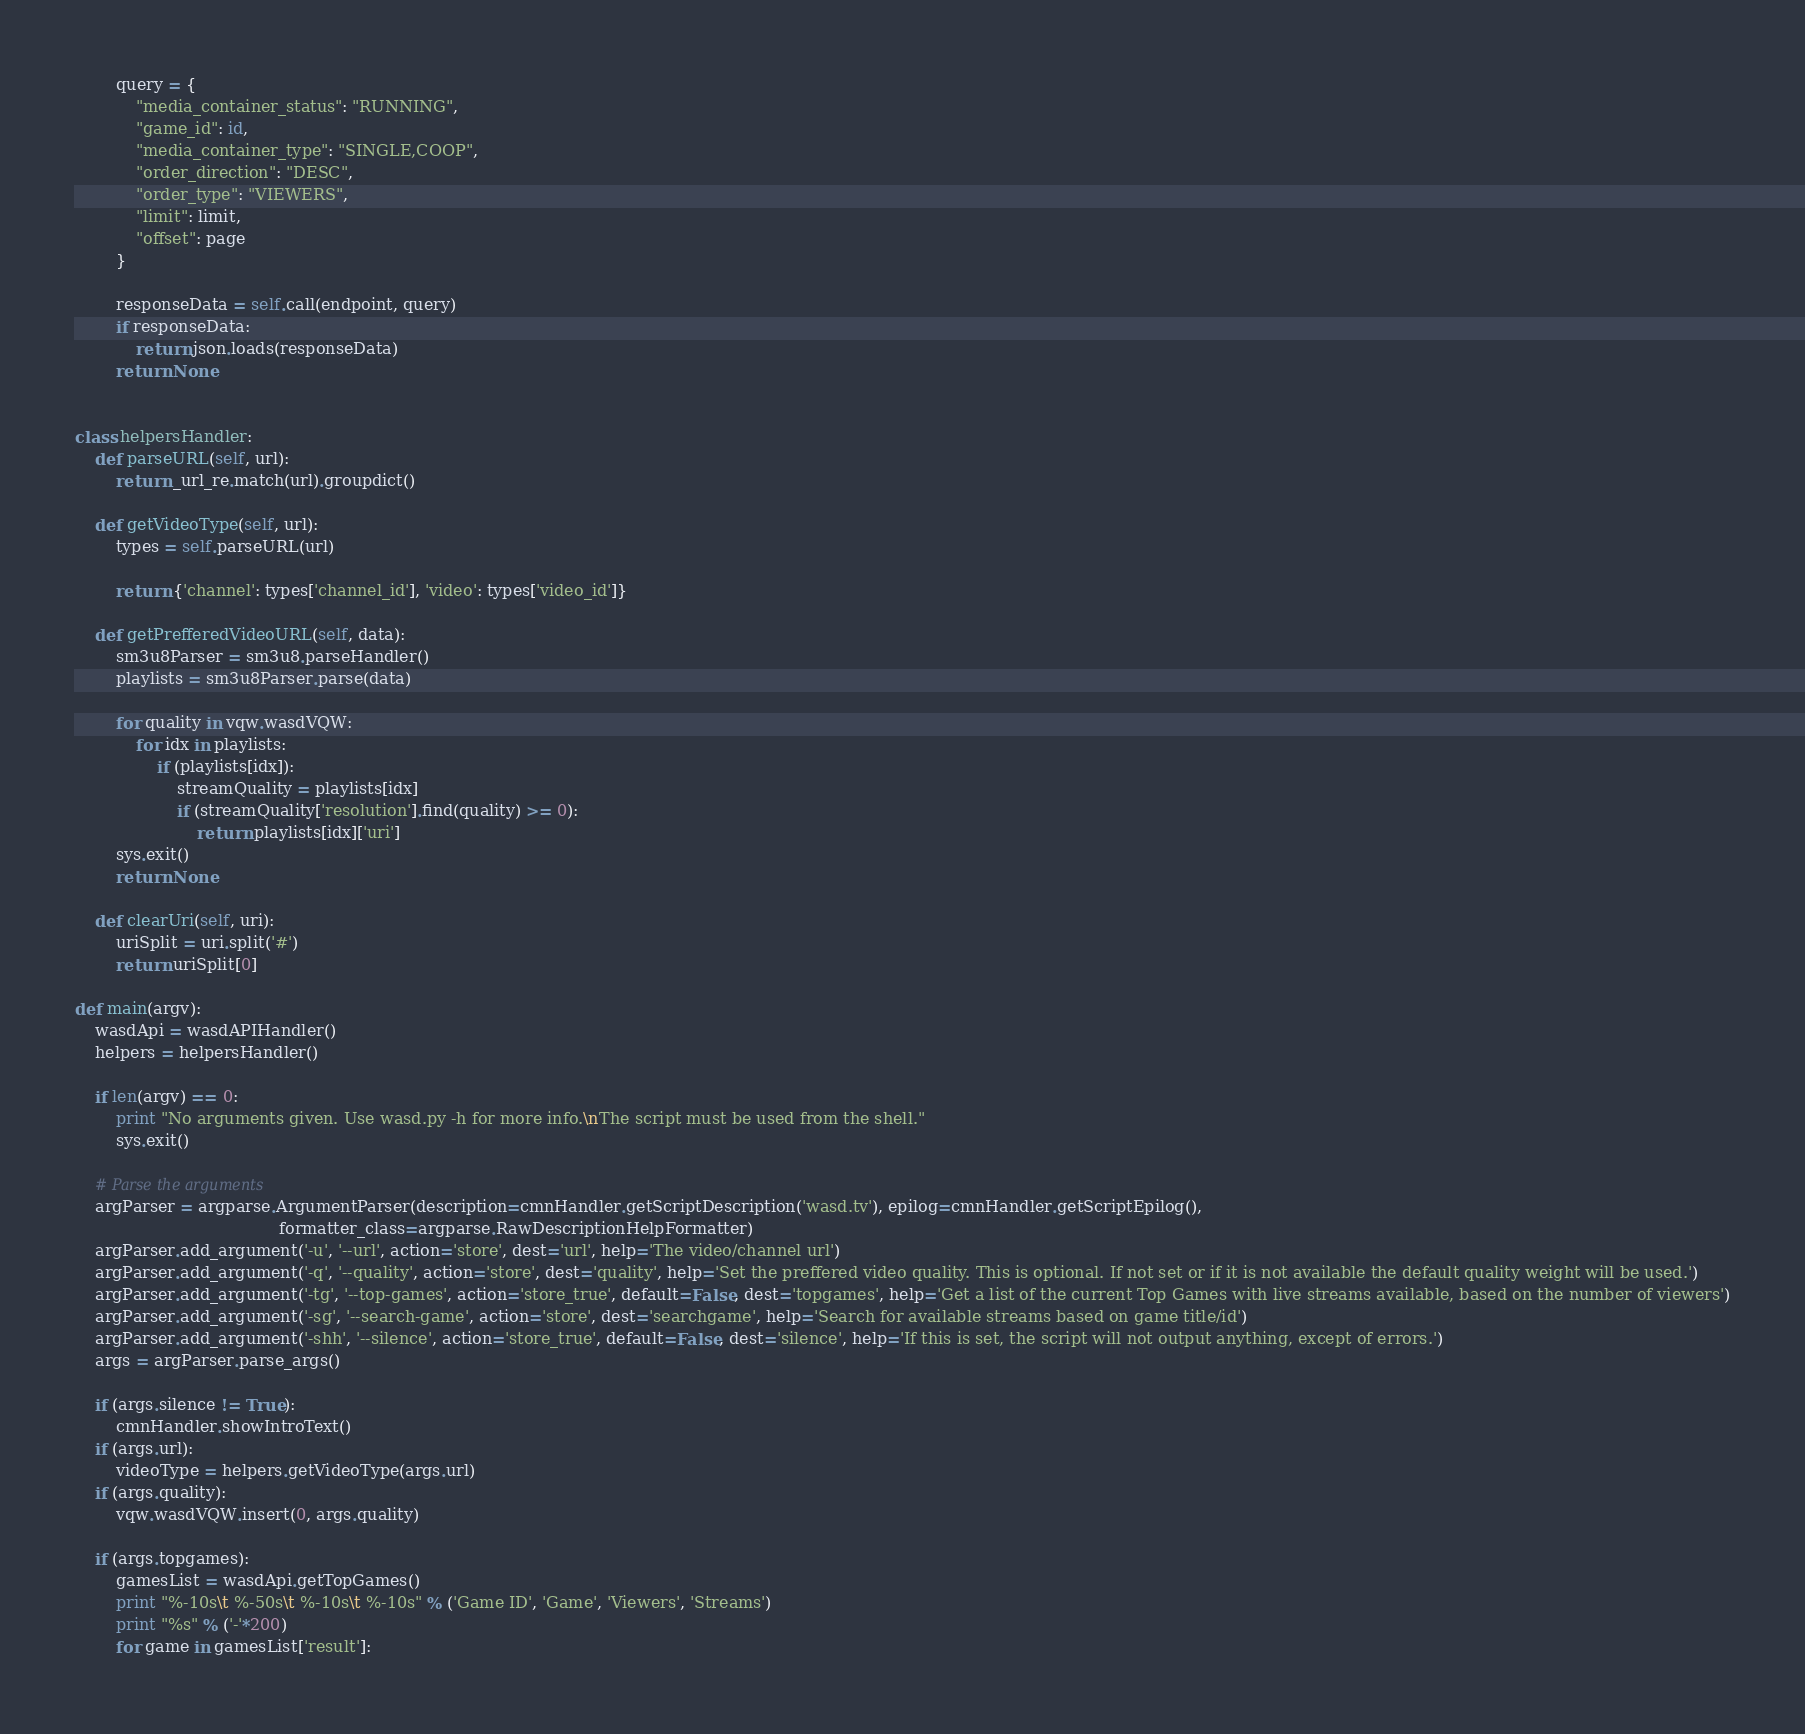Convert code to text. <code><loc_0><loc_0><loc_500><loc_500><_Python_>        query = {
            "media_container_status": "RUNNING",
            "game_id": id,
            "media_container_type": "SINGLE,COOP",
            "order_direction": "DESC",
            "order_type": "VIEWERS",
            "limit": limit,
            "offset": page
        }

        responseData = self.call(endpoint, query)
        if responseData:
            return json.loads(responseData)
        return None


class helpersHandler:
    def parseURL(self, url):
        return _url_re.match(url).groupdict()

    def getVideoType(self, url):
        types = self.parseURL(url)

        return {'channel': types['channel_id'], 'video': types['video_id']}

    def getPrefferedVideoURL(self, data):
        sm3u8Parser = sm3u8.parseHandler()
        playlists = sm3u8Parser.parse(data)
        
        for quality in vqw.wasdVQW:
            for idx in playlists:
                if (playlists[idx]):
                    streamQuality = playlists[idx]
                    if (streamQuality['resolution'].find(quality) >= 0):
                        return playlists[idx]['uri']
        sys.exit()
        return None
        
    def clearUri(self, uri):
        uriSplit = uri.split('#')
        return uriSplit[0]

def main(argv):
    wasdApi = wasdAPIHandler()
    helpers = helpersHandler()

    if len(argv) == 0:
        print "No arguments given. Use wasd.py -h for more info.\nThe script must be used from the shell."
        sys.exit()
        
    # Parse the arguments
    argParser = argparse.ArgumentParser(description=cmnHandler.getScriptDescription('wasd.tv'), epilog=cmnHandler.getScriptEpilog(),
                                        formatter_class=argparse.RawDescriptionHelpFormatter)
    argParser.add_argument('-u', '--url', action='store', dest='url', help='The video/channel url')
    argParser.add_argument('-q', '--quality', action='store', dest='quality', help='Set the preffered video quality. This is optional. If not set or if it is not available the default quality weight will be used.')
    argParser.add_argument('-tg', '--top-games', action='store_true', default=False, dest='topgames', help='Get a list of the current Top Games with live streams available, based on the number of viewers')
    argParser.add_argument('-sg', '--search-game', action='store', dest='searchgame', help='Search for available streams based on game title/id')
    argParser.add_argument('-shh', '--silence', action='store_true', default=False, dest='silence', help='If this is set, the script will not output anything, except of errors.')
    args = argParser.parse_args()

    if (args.silence != True):
        cmnHandler.showIntroText()
    if (args.url):
        videoType = helpers.getVideoType(args.url)
    if (args.quality):
        vqw.wasdVQW.insert(0, args.quality)

    if (args.topgames):
        gamesList = wasdApi.getTopGames()
        print "%-10s\t %-50s\t %-10s\t %-10s" % ('Game ID', 'Game', 'Viewers', 'Streams')
        print "%s" % ('-'*200)
        for game in gamesList['result']:</code> 